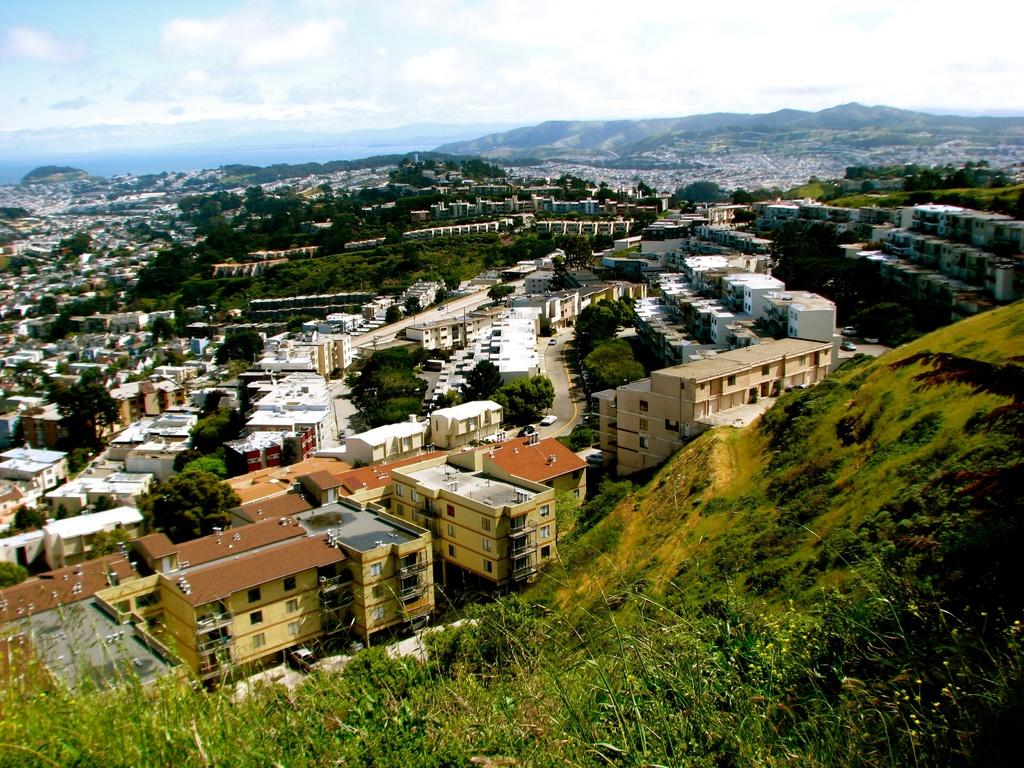What type of view is shown in the image? The image is an aerial view. What can be seen on the ground in the image? There are roads, vehicles, trees, plants, hills, grass, and buildings visible in the image. What is visible in the sky in the image? The sky is visible in the image, along with clouds. What type of journey is the mountain taking in the image? There is no mountain present in the image, so it cannot be taking a journey. 